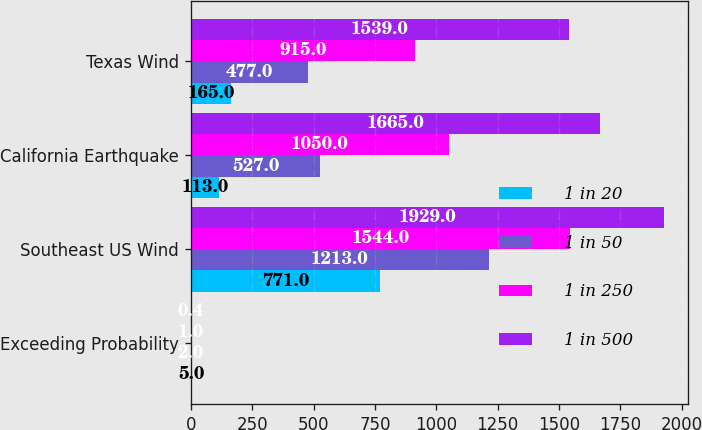Convert chart to OTSL. <chart><loc_0><loc_0><loc_500><loc_500><stacked_bar_chart><ecel><fcel>Exceeding Probability<fcel>Southeast US Wind<fcel>California Earthquake<fcel>Texas Wind<nl><fcel>1 in 20<fcel>5<fcel>771<fcel>113<fcel>165<nl><fcel>1 in 50<fcel>2<fcel>1213<fcel>527<fcel>477<nl><fcel>1 in 250<fcel>1<fcel>1544<fcel>1050<fcel>915<nl><fcel>1 in 500<fcel>0.4<fcel>1929<fcel>1665<fcel>1539<nl></chart> 